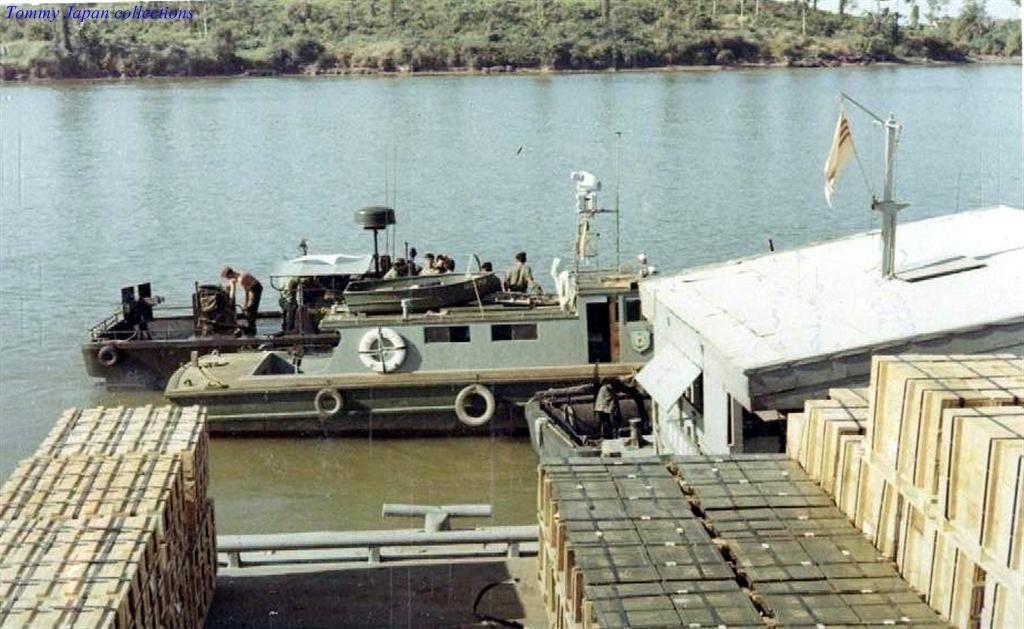Could you give a brief overview of what you see in this image? In this picture, we see men on the sailing ship. We see water. This water might be in the lake. At the bottom of the picture, we see containers and a white color building type. We see a flag in cream and maroon color. There are trees in the background. 